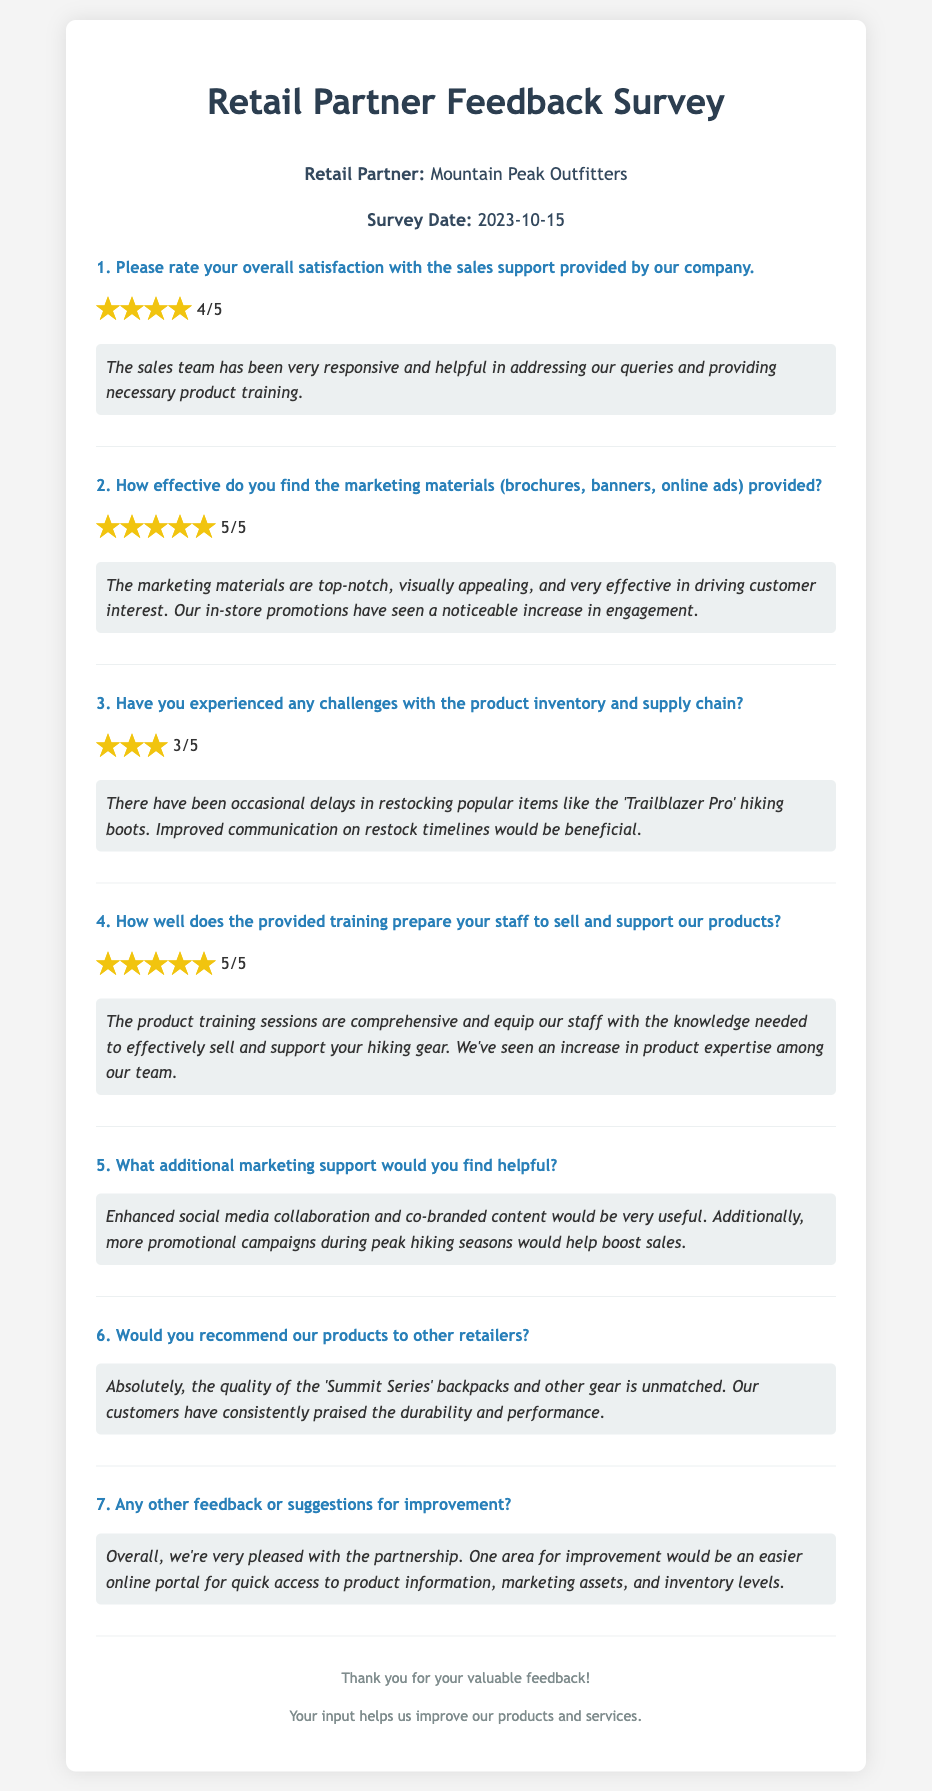What is the name of the retail partner? The retail partner is identified at the beginning of the document as "Mountain Peak Outfitters."
Answer: Mountain Peak Outfitters When was the survey conducted? The survey date is listed directly under the retail partner's name in the document, which is "2023-10-15."
Answer: 2023-10-15 What is the satisfaction rating for sales support? The overall satisfaction rating for sales support is represented, which is "4/5."
Answer: 4/5 How effective are the marketing materials according to the feedback? The effectiveness rating for the marketing materials is given as "5/5."
Answer: 5/5 What is a suggested area for improvement mentioned in the feedback? The feedback contains a suggestion for improvement regarding "an easier online portal for quick access."
Answer: easier online portal What additional marketing support is requested? One additional marketing support requested in the feedback is "enhanced social media collaboration."
Answer: enhanced social media collaboration How did the training prepare the staff according to the feedback? The feedback states that the training "equipped our staff with the knowledge needed" to sell and support the products.
Answer: equipped our staff What product experienced occasional inventory delays? The document mentions "Trailblazer Pro" hiking boots as experiencing delays in inventory.
Answer: Trailblazer Pro Would the retail partner recommend the products to other retailers? According to the feedback, the retail partner would "absolutely" recommend the products to others.
Answer: absolutely 